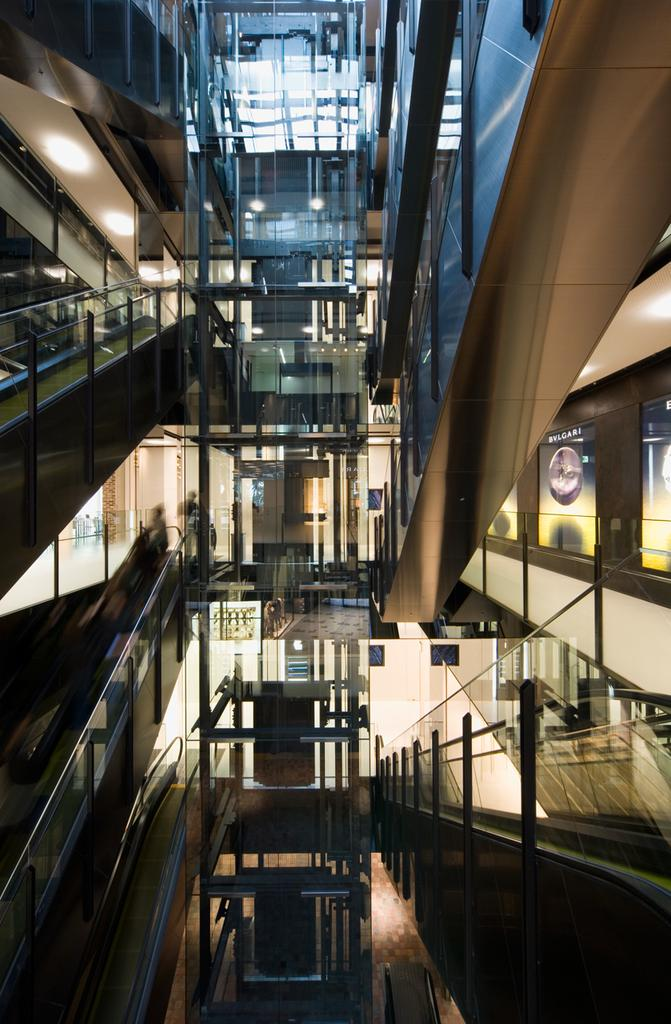Where was the image taken? The image was taken inside a building. What architectural feature can be seen in the image? There are staircases in the image. What type of coach is visible in the image? There is no coach present in the image; it was taken inside a building with staircases. 